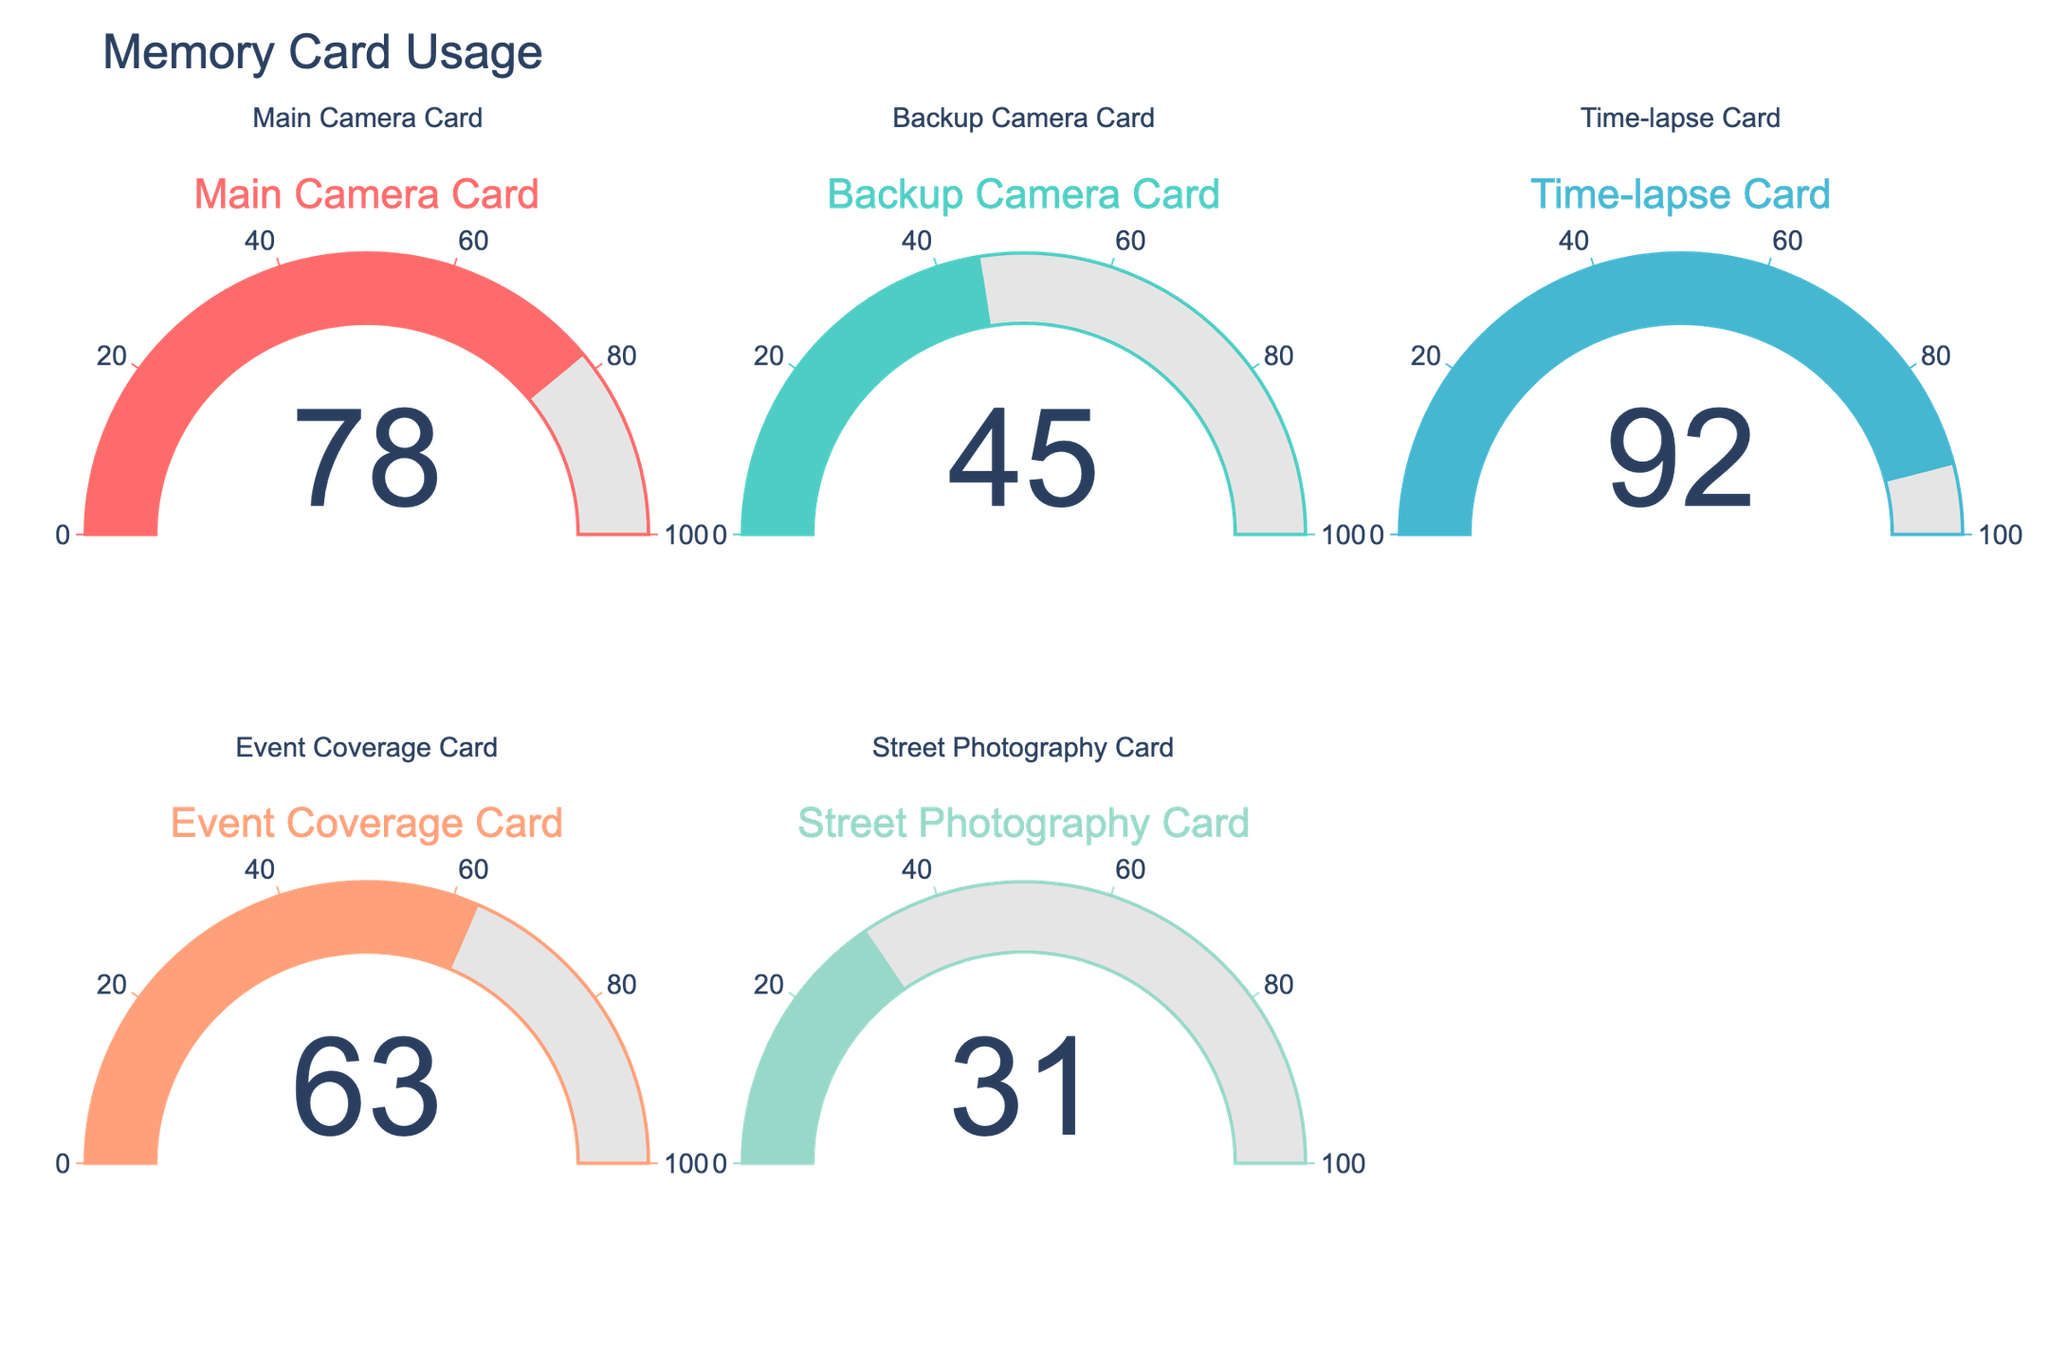what is the highest percentage of digital storage used on the memory cards? The highest storage percentage used can be found by identifying the gauge chart with the largest number. From the gauge charts, 92% is the highest value, which corresponds to the Time-lapse Card.
Answer: 92% Which cards have more than 50% of their digital storage used? By examining the gauge charts, we can see which gauges display numbers greater than 50. The Main Camera Card (78%), Time-lapse Card (92%), and Event Coverage Card (63%) all have more than 50% of their storage used.
Answer: Main Camera Card, Time-lapse Card, Event Coverage Card Which memory card has used the least amount of digital storage? To find the least used storage, we need to identify the gauge chart with the lowest number. The Street Photography Card is at 31%, which is the lowest percentage among the cards.
Answer: Street Photography Card What’s the average percentage of digital storage used across all the memory cards? To calculate the average, sum the percentages and divide by the number of cards. (78 + 45 + 92 + 63 + 31) / 5 = 309 / 5 = 61.8
Answer: 61.8% By how much does the storage use of the Time-lapse Card exceed the Backup Camera Card? The Time-lapse Card shows 92% usage, and the Backup Camera Card shows 45%. The difference is 92 - 45 = 47.
Answer: 47% What is the total percentage of digital storage used if we combine the Main Camera Card and the Event Coverage Card? By adding the percentages of these two cards: 78 + 63 = 141.
Answer: 141% Are any two cards using exactly the same percentage of digital storage? By examining the gauge charts, each card displays a unique percentage (78, 45, 92, 63, 31). No two cards have the same value.
Answer: No Which memory card has a usage percentage closest to the average usage of all cards? The average usage is 61.8%. Compare this average to each of the card's percentages: Main Camera Card (78), Backup Camera Card (45), Time-lapse Card (92), Event Coverage Card (63), Street Photography Card (31). The closest value is the Event Coverage Card at 63%.
Answer: Event Coverage Card What is the difference in digital storage use between the Street Photography Card and the Main Camera Card? The Main Camera Card shows 78% usage, and the Street Photography Card shows 31%. The difference is 78 - 31 = 47.
Answer: 47% Which memory card falls below the halfway point (50%) of its digital storage usage? By evaluating the gauge charts, we see that the Backup Camera Card (45%) and the Street Photography Card (31%) fall below the 50% mark.
Answer: Backup Camera Card, Street Photography Card 